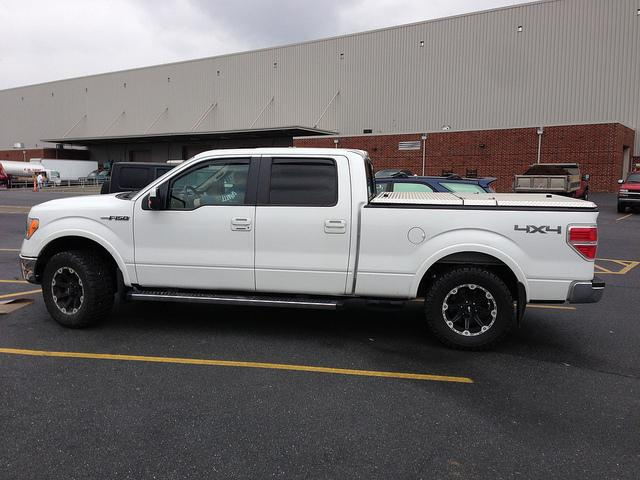What is the answer to the equation on the side of the truck?

Choices:
A) 72
B) 24
C) 16
D) 89 16 